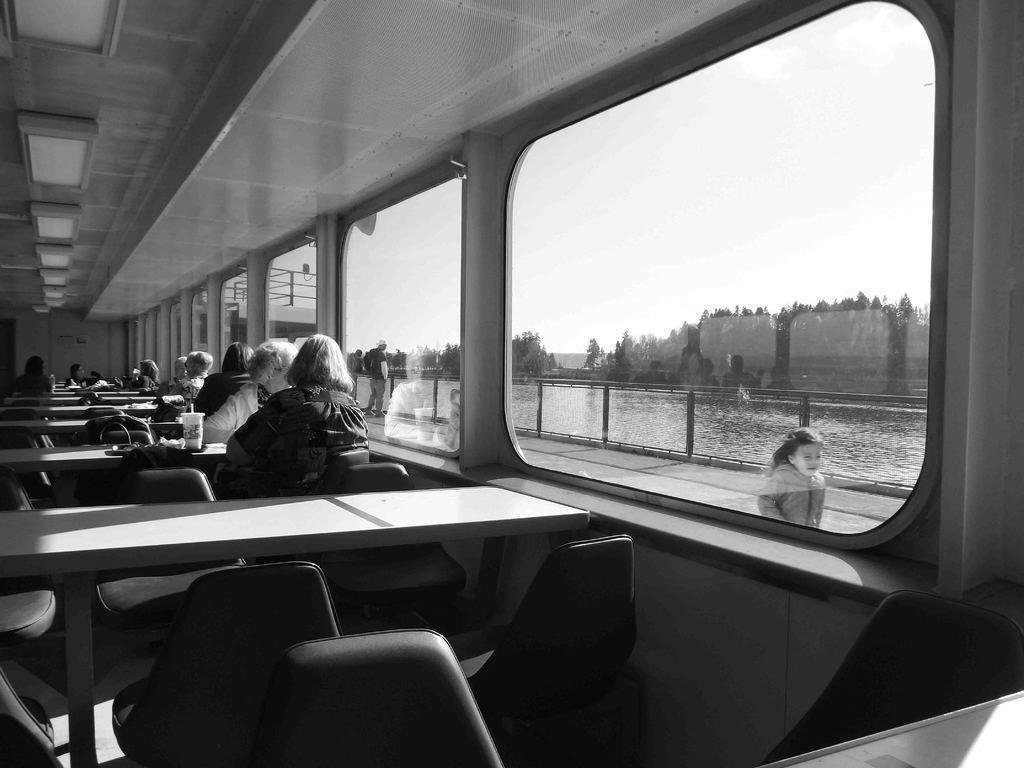Can you describe this image briefly? In the picture we can see inside the restaurant with tables, chairs and some person sitting and on the table, we can see a tray and on it we can see a glass and straw in it and outside the restaurant we can see a path with a girl standing and in the path we can see railing and behind it we can see water and in the background we can see trees and sky. 